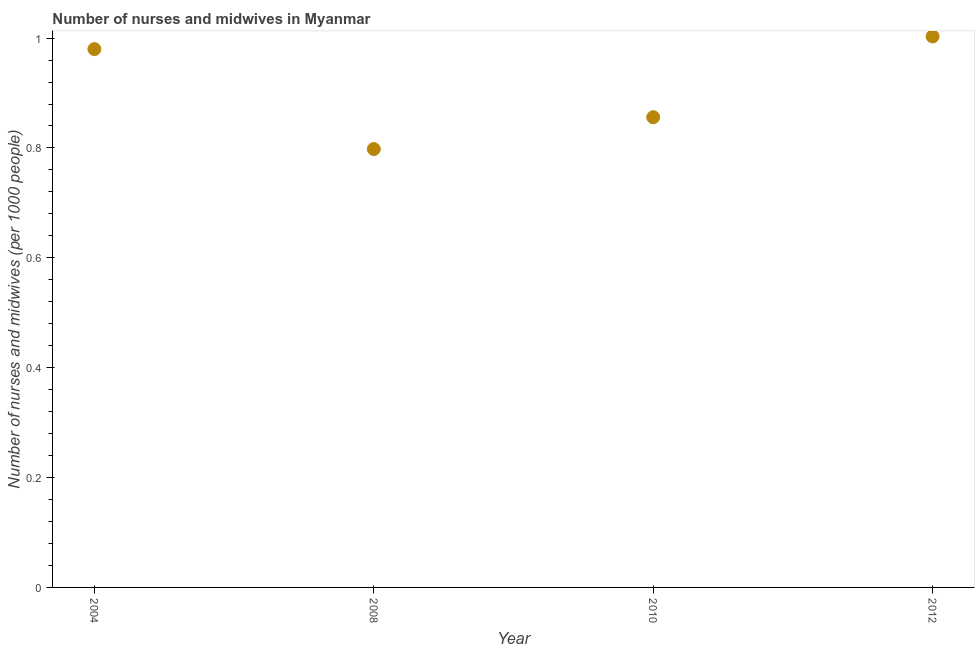What is the number of nurses and midwives in 2012?
Keep it short and to the point. 1. Across all years, what is the maximum number of nurses and midwives?
Your response must be concise. 1. Across all years, what is the minimum number of nurses and midwives?
Ensure brevity in your answer.  0.8. In which year was the number of nurses and midwives maximum?
Provide a succinct answer. 2012. What is the sum of the number of nurses and midwives?
Give a very brief answer. 3.64. What is the difference between the number of nurses and midwives in 2008 and 2010?
Your response must be concise. -0.06. What is the average number of nurses and midwives per year?
Your answer should be compact. 0.91. What is the median number of nurses and midwives?
Your response must be concise. 0.92. In how many years, is the number of nurses and midwives greater than 0.04 ?
Keep it short and to the point. 4. Do a majority of the years between 2012 and 2004 (inclusive) have number of nurses and midwives greater than 0.56 ?
Provide a succinct answer. Yes. What is the ratio of the number of nurses and midwives in 2004 to that in 2008?
Provide a succinct answer. 1.23. What is the difference between the highest and the second highest number of nurses and midwives?
Your answer should be compact. 0.02. What is the difference between the highest and the lowest number of nurses and midwives?
Make the answer very short. 0.2. Does the number of nurses and midwives monotonically increase over the years?
Your response must be concise. No. How many dotlines are there?
Provide a succinct answer. 1. Are the values on the major ticks of Y-axis written in scientific E-notation?
Keep it short and to the point. No. What is the title of the graph?
Provide a short and direct response. Number of nurses and midwives in Myanmar. What is the label or title of the X-axis?
Your answer should be compact. Year. What is the label or title of the Y-axis?
Your response must be concise. Number of nurses and midwives (per 1000 people). What is the Number of nurses and midwives (per 1000 people) in 2008?
Your response must be concise. 0.8. What is the Number of nurses and midwives (per 1000 people) in 2010?
Your response must be concise. 0.86. What is the Number of nurses and midwives (per 1000 people) in 2012?
Provide a short and direct response. 1. What is the difference between the Number of nurses and midwives (per 1000 people) in 2004 and 2008?
Your answer should be compact. 0.18. What is the difference between the Number of nurses and midwives (per 1000 people) in 2004 and 2010?
Offer a very short reply. 0.12. What is the difference between the Number of nurses and midwives (per 1000 people) in 2004 and 2012?
Your response must be concise. -0.02. What is the difference between the Number of nurses and midwives (per 1000 people) in 2008 and 2010?
Your response must be concise. -0.06. What is the difference between the Number of nurses and midwives (per 1000 people) in 2008 and 2012?
Offer a terse response. -0.2. What is the difference between the Number of nurses and midwives (per 1000 people) in 2010 and 2012?
Make the answer very short. -0.15. What is the ratio of the Number of nurses and midwives (per 1000 people) in 2004 to that in 2008?
Provide a succinct answer. 1.23. What is the ratio of the Number of nurses and midwives (per 1000 people) in 2004 to that in 2010?
Provide a succinct answer. 1.15. What is the ratio of the Number of nurses and midwives (per 1000 people) in 2008 to that in 2010?
Your answer should be compact. 0.93. What is the ratio of the Number of nurses and midwives (per 1000 people) in 2008 to that in 2012?
Offer a terse response. 0.8. What is the ratio of the Number of nurses and midwives (per 1000 people) in 2010 to that in 2012?
Offer a very short reply. 0.85. 